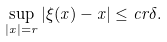<formula> <loc_0><loc_0><loc_500><loc_500>\sup _ { | x | = r } \left | \xi ( x ) - x \right | \leq c r \delta .</formula> 